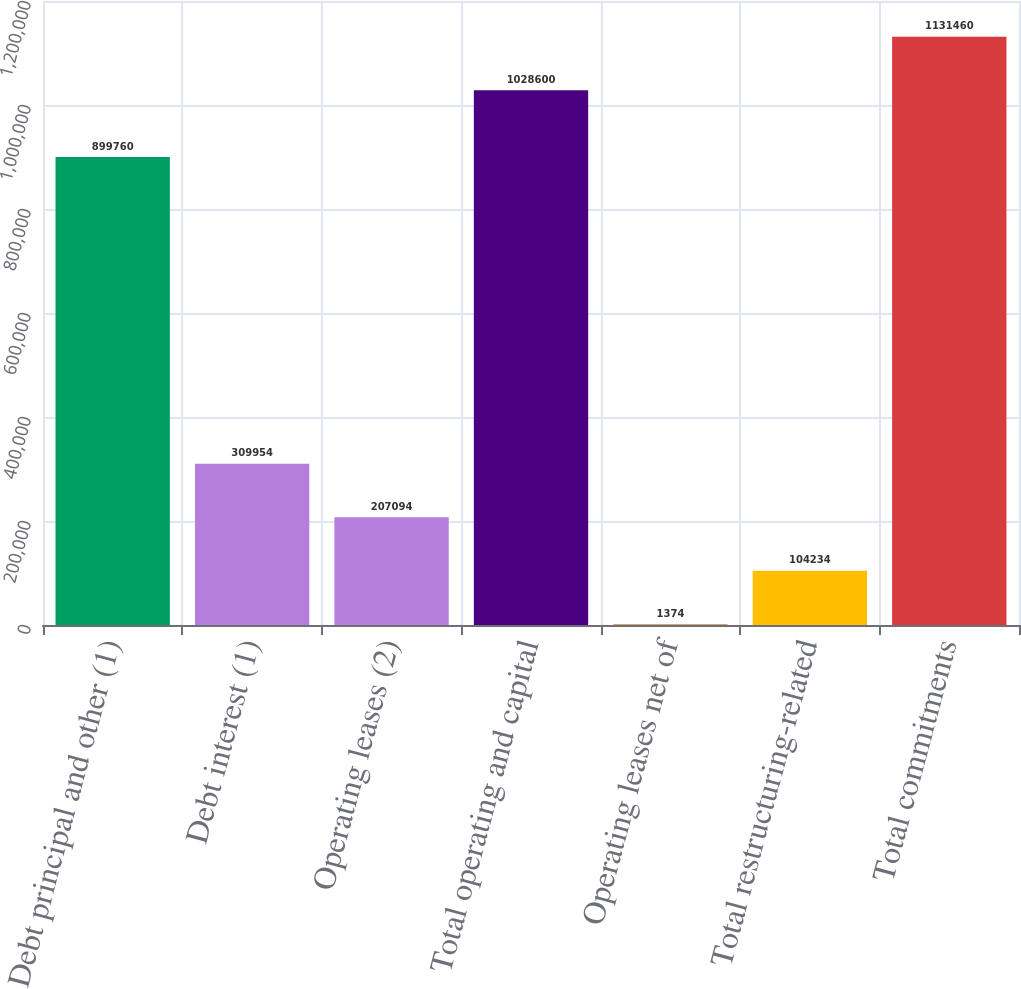<chart> <loc_0><loc_0><loc_500><loc_500><bar_chart><fcel>Debt principal and other (1)<fcel>Debt interest (1)<fcel>Operating leases (2)<fcel>Total operating and capital<fcel>Operating leases net of<fcel>Total restructuring-related<fcel>Total commitments<nl><fcel>899760<fcel>309954<fcel>207094<fcel>1.0286e+06<fcel>1374<fcel>104234<fcel>1.13146e+06<nl></chart> 